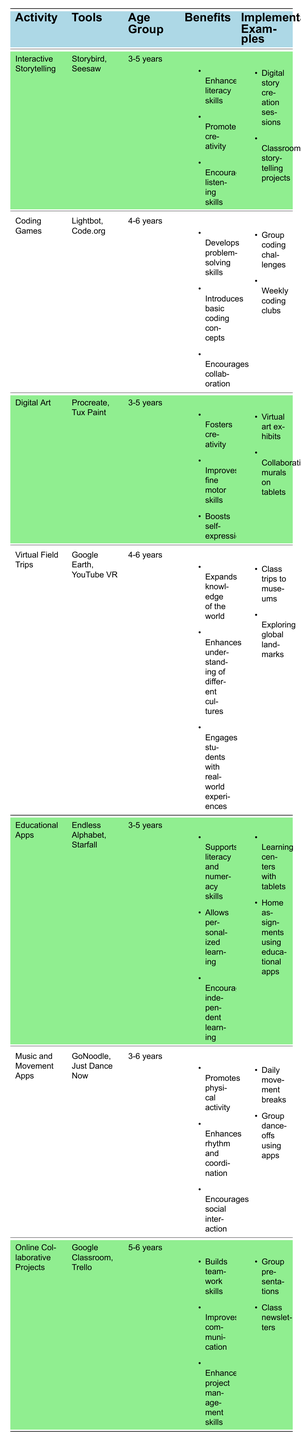What activity supports literacy skills for 3-5 years? The table lists "Interactive Storytelling" as an activity for the age group 3-5 years that enhances literacy skills.
Answer: Interactive Storytelling Which tools are used for coding games? The table specifies that "Lightbot" and "Code.org" are the tools used for the activity "Coding Games."
Answer: Lightbot, Code.org Does "Digital Art" benefit fine motor skills? Yes, "Digital Art" is listed in the table with benefits that include improving fine motor skills.
Answer: Yes What are the benefits of "Educational Apps"? The table lists three benefits: supports literacy and numeracy skills, allows personalized learning, and encourages independent learning for the activity "Educational Apps."
Answer: Supports literacy and numeracy skills, allows personalized learning, encourages independent learning Which activity has tools related to music? The activity "Music and Movement Apps" is identified in the table, which includes tools such as "GoNoodle" and "Just Dance Now."
Answer: Music and Movement Apps How many activities are targeted at the age group 5-6 years? There are two activities in the table for the age group 5-6 years: "Coding Games" and "Online Collaborative Projects."
Answer: 2 What are some implementation examples of "Virtual Field Trips"? The activity "Virtual Field Trips" includes implementation examples such as class trips to museums and exploring global landmarks, as detailed in the table.
Answer: Class trips to museums, exploring global landmarks Are there any activities that encourage social interaction? Yes, both "Music and Movement Apps" and "Online Collaborative Projects" encourage social interaction based on the benefits listed in the table.
Answer: Yes Which activity has the most implementation examples listed? The table shows that "Coding Games," "Virtual Field Trips," and "Online Collaborative Projects" each have two implementation examples listed, while others have one or two. Since multiple activities have the same count, the answer reflects that.
Answer: Multiple activities (2 examples each) What is the age range for "Interactive Storytelling" and "Digital Art"? Both "Interactive Storytelling" and "Digital Art" target the age group of 3-5 years as indicated in the table.
Answer: 3-5 years Which tool is used for enhancing creativity in the classroom? "Procreate" is listed under "Digital Art," which is focused on enhancing creativity among children.
Answer: Procreate 